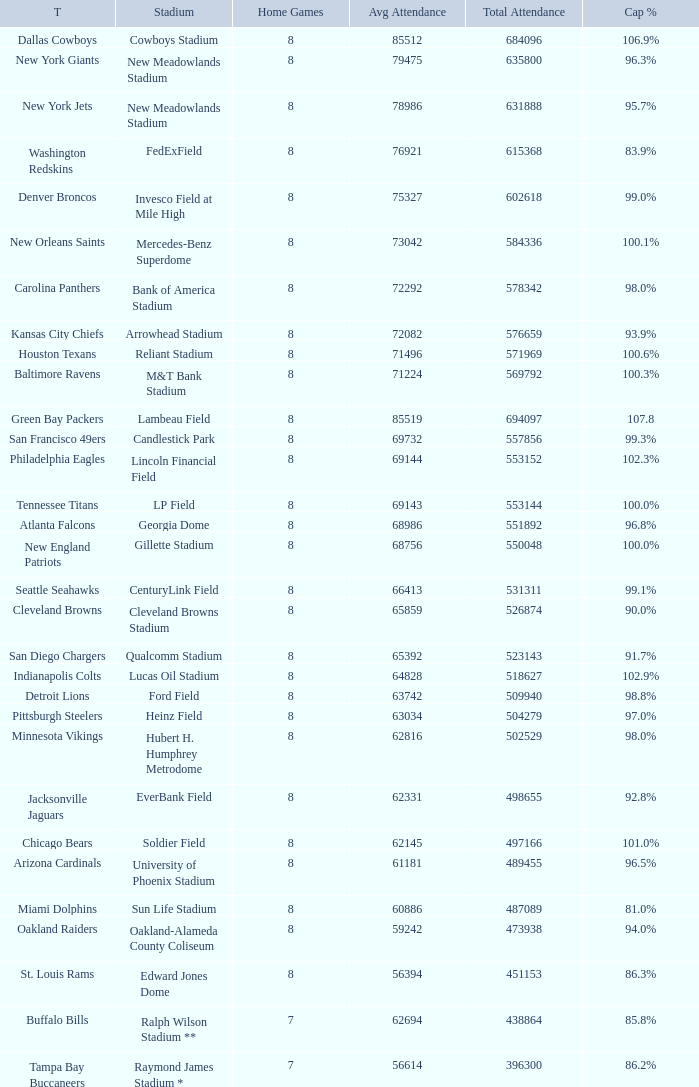What is the capacity percentage when the total attendance is 509940? 98.8%. 